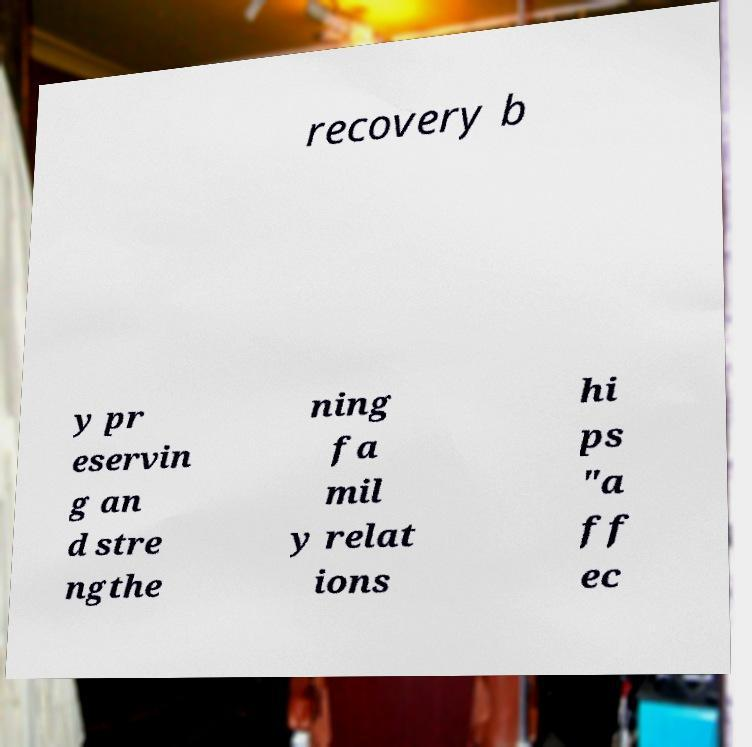Please read and relay the text visible in this image. What does it say? recovery b y pr eservin g an d stre ngthe ning fa mil y relat ions hi ps "a ff ec 